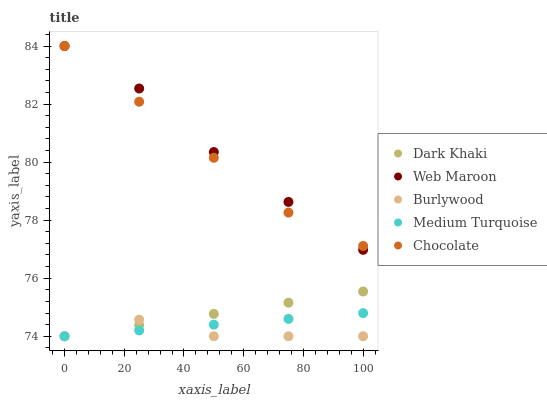Does Burlywood have the minimum area under the curve?
Answer yes or no. Yes. Does Web Maroon have the maximum area under the curve?
Answer yes or no. Yes. Does Web Maroon have the minimum area under the curve?
Answer yes or no. No. Does Burlywood have the maximum area under the curve?
Answer yes or no. No. Is Medium Turquoise the smoothest?
Answer yes or no. Yes. Is Burlywood the roughest?
Answer yes or no. Yes. Is Web Maroon the smoothest?
Answer yes or no. No. Is Web Maroon the roughest?
Answer yes or no. No. Does Dark Khaki have the lowest value?
Answer yes or no. Yes. Does Web Maroon have the lowest value?
Answer yes or no. No. Does Chocolate have the highest value?
Answer yes or no. Yes. Does Burlywood have the highest value?
Answer yes or no. No. Is Burlywood less than Web Maroon?
Answer yes or no. Yes. Is Chocolate greater than Medium Turquoise?
Answer yes or no. Yes. Does Web Maroon intersect Chocolate?
Answer yes or no. Yes. Is Web Maroon less than Chocolate?
Answer yes or no. No. Is Web Maroon greater than Chocolate?
Answer yes or no. No. Does Burlywood intersect Web Maroon?
Answer yes or no. No. 